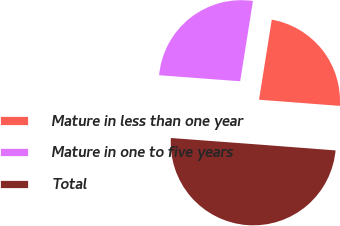Convert chart to OTSL. <chart><loc_0><loc_0><loc_500><loc_500><pie_chart><fcel>Mature in less than one year<fcel>Mature in one to five years<fcel>Total<nl><fcel>23.7%<fcel>26.33%<fcel>49.97%<nl></chart> 